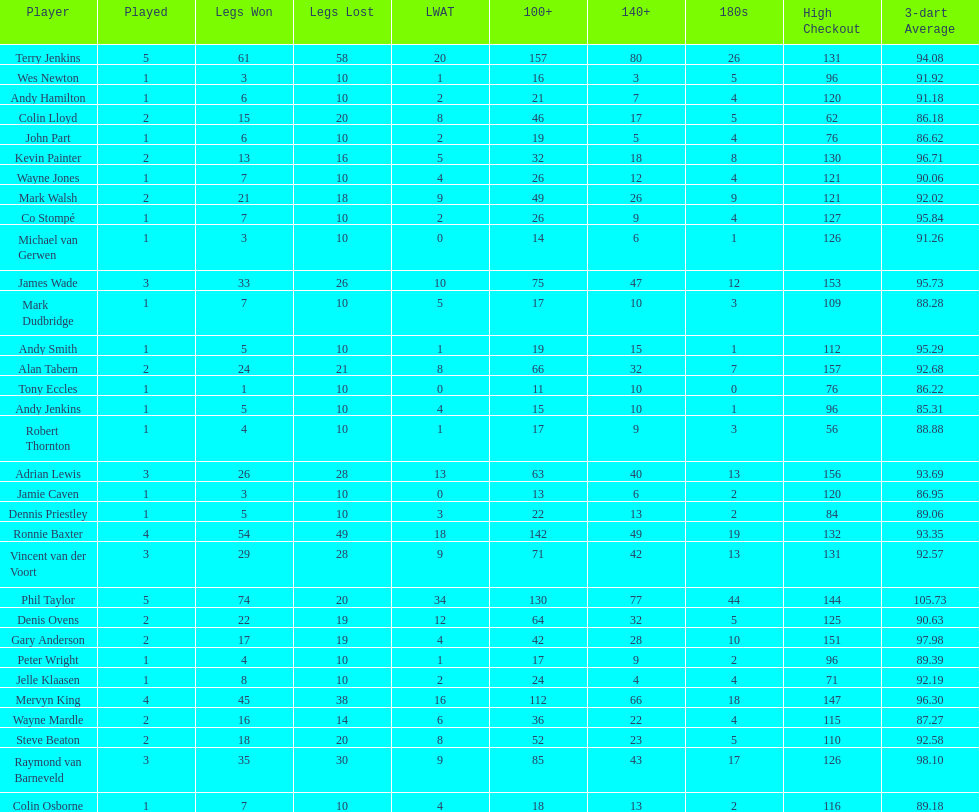How many players in the 2009 world matchplay won at least 30 legs? 6. 